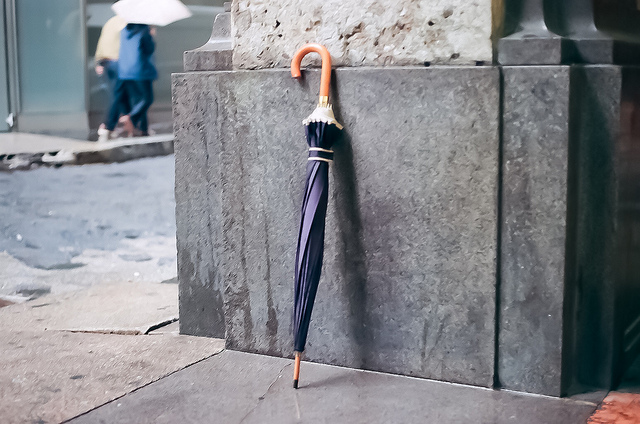What is the weather like in the image? It's difficult to determine the current weather conditions definitively from the image alone, but the presence of the umbrella suggests it might have been raining or there's a chance of rain. Do you see any other indicators of weather? The ground appears to be dry, and shadows are visible, which could indicate that the weather has cleared up after rain or the umbrella is being carried just in case. 